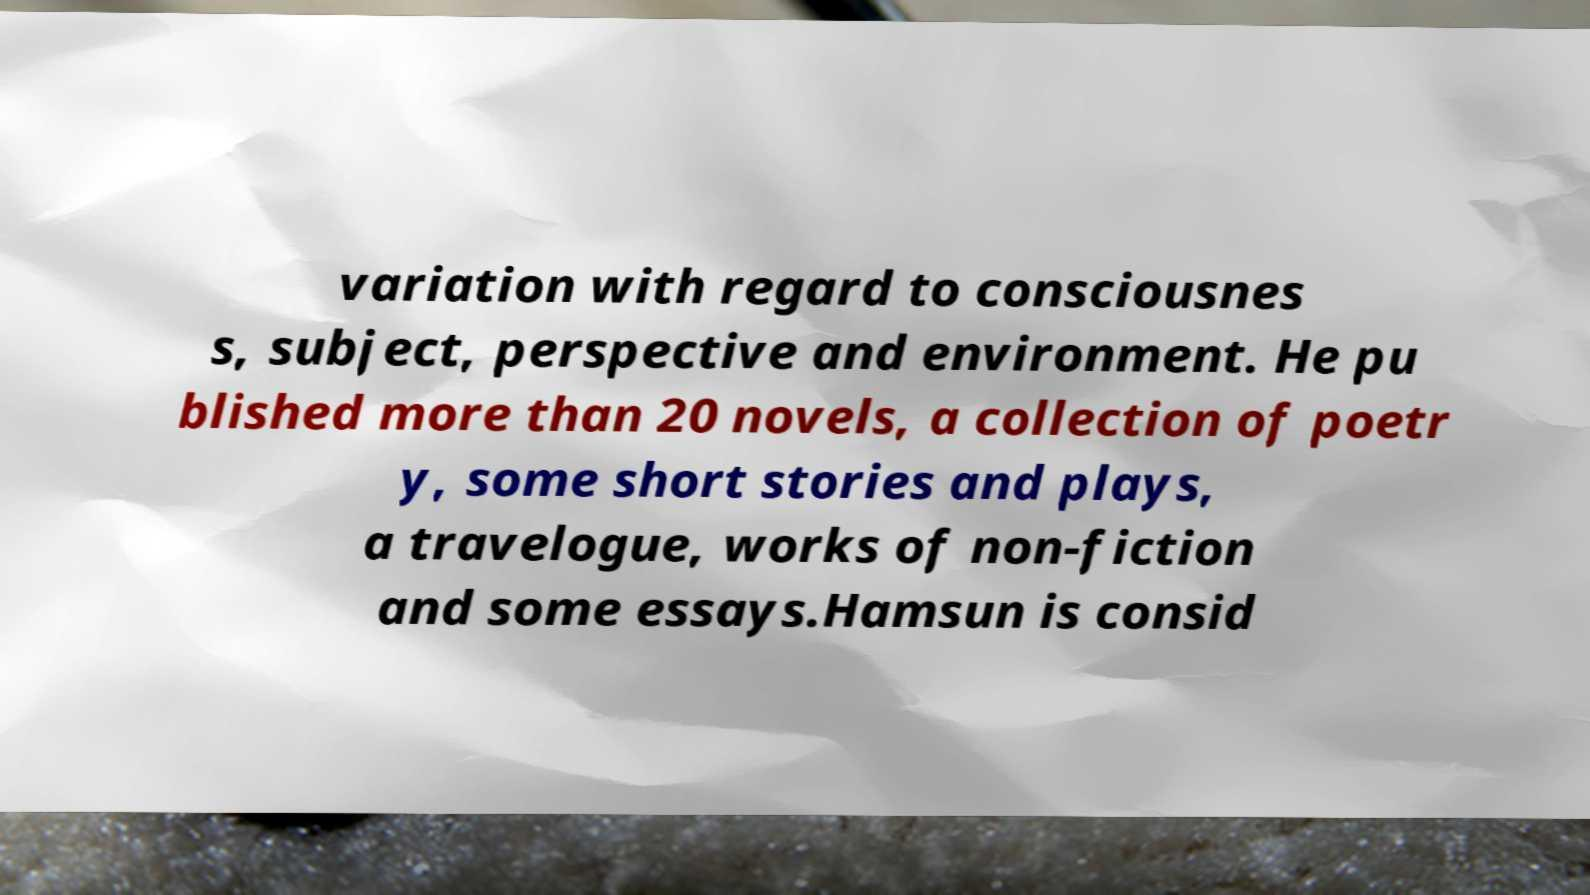Could you extract and type out the text from this image? variation with regard to consciousnes s, subject, perspective and environment. He pu blished more than 20 novels, a collection of poetr y, some short stories and plays, a travelogue, works of non-fiction and some essays.Hamsun is consid 